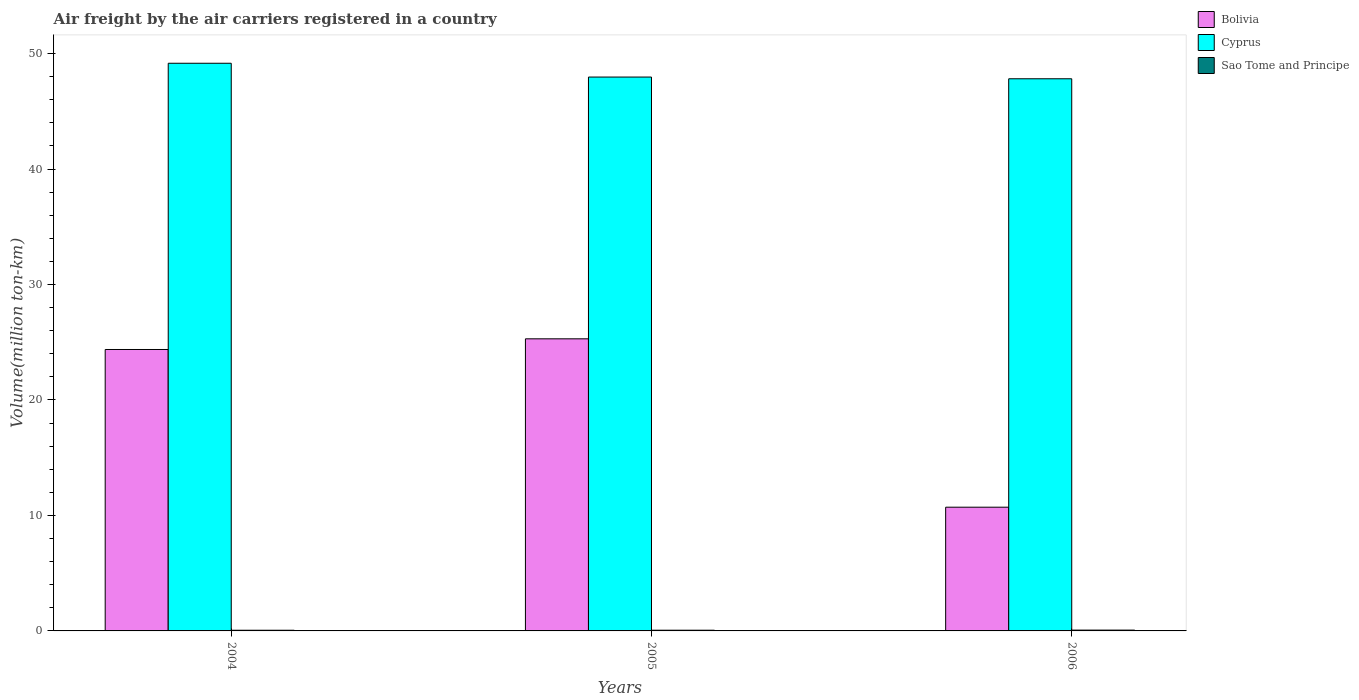Are the number of bars per tick equal to the number of legend labels?
Provide a short and direct response. Yes. Are the number of bars on each tick of the X-axis equal?
Make the answer very short. Yes. How many bars are there on the 1st tick from the right?
Offer a terse response. 3. In how many cases, is the number of bars for a given year not equal to the number of legend labels?
Ensure brevity in your answer.  0. What is the volume of the air carriers in Cyprus in 2006?
Provide a succinct answer. 47.81. Across all years, what is the maximum volume of the air carriers in Sao Tome and Principe?
Provide a succinct answer. 0.07. Across all years, what is the minimum volume of the air carriers in Cyprus?
Ensure brevity in your answer.  47.81. In which year was the volume of the air carriers in Bolivia minimum?
Give a very brief answer. 2006. What is the total volume of the air carriers in Sao Tome and Principe in the graph?
Offer a terse response. 0.19. What is the difference between the volume of the air carriers in Sao Tome and Principe in 2005 and that in 2006?
Your answer should be very brief. -0.01. What is the difference between the volume of the air carriers in Bolivia in 2005 and the volume of the air carriers in Sao Tome and Principe in 2006?
Your answer should be compact. 25.22. What is the average volume of the air carriers in Sao Tome and Principe per year?
Provide a short and direct response. 0.06. In the year 2004, what is the difference between the volume of the air carriers in Cyprus and volume of the air carriers in Sao Tome and Principe?
Your answer should be very brief. 49.1. In how many years, is the volume of the air carriers in Cyprus greater than 4 million ton-km?
Offer a terse response. 3. What is the ratio of the volume of the air carriers in Cyprus in 2004 to that in 2006?
Your response must be concise. 1.03. Is the volume of the air carriers in Sao Tome and Principe in 2004 less than that in 2006?
Provide a succinct answer. Yes. Is the difference between the volume of the air carriers in Cyprus in 2005 and 2006 greater than the difference between the volume of the air carriers in Sao Tome and Principe in 2005 and 2006?
Make the answer very short. Yes. What is the difference between the highest and the second highest volume of the air carriers in Cyprus?
Offer a very short reply. 1.2. What is the difference between the highest and the lowest volume of the air carriers in Cyprus?
Give a very brief answer. 1.34. In how many years, is the volume of the air carriers in Cyprus greater than the average volume of the air carriers in Cyprus taken over all years?
Ensure brevity in your answer.  1. What does the 3rd bar from the left in 2005 represents?
Give a very brief answer. Sao Tome and Principe. What does the 2nd bar from the right in 2006 represents?
Your answer should be very brief. Cyprus. How many years are there in the graph?
Offer a terse response. 3. What is the difference between two consecutive major ticks on the Y-axis?
Make the answer very short. 10. Does the graph contain any zero values?
Provide a short and direct response. No. Where does the legend appear in the graph?
Offer a terse response. Top right. How are the legend labels stacked?
Your answer should be very brief. Vertical. What is the title of the graph?
Your answer should be very brief. Air freight by the air carriers registered in a country. What is the label or title of the X-axis?
Provide a short and direct response. Years. What is the label or title of the Y-axis?
Provide a succinct answer. Volume(million ton-km). What is the Volume(million ton-km) of Bolivia in 2004?
Make the answer very short. 24.37. What is the Volume(million ton-km) in Cyprus in 2004?
Offer a terse response. 49.16. What is the Volume(million ton-km) in Sao Tome and Principe in 2004?
Ensure brevity in your answer.  0.06. What is the Volume(million ton-km) of Bolivia in 2005?
Offer a terse response. 25.3. What is the Volume(million ton-km) in Cyprus in 2005?
Ensure brevity in your answer.  47.96. What is the Volume(million ton-km) of Sao Tome and Principe in 2005?
Your answer should be very brief. 0.06. What is the Volume(million ton-km) of Bolivia in 2006?
Make the answer very short. 10.71. What is the Volume(million ton-km) of Cyprus in 2006?
Provide a short and direct response. 47.81. What is the Volume(million ton-km) in Sao Tome and Principe in 2006?
Your answer should be very brief. 0.07. Across all years, what is the maximum Volume(million ton-km) of Bolivia?
Provide a succinct answer. 25.3. Across all years, what is the maximum Volume(million ton-km) of Cyprus?
Your response must be concise. 49.16. Across all years, what is the maximum Volume(million ton-km) in Sao Tome and Principe?
Offer a terse response. 0.07. Across all years, what is the minimum Volume(million ton-km) of Bolivia?
Your answer should be compact. 10.71. Across all years, what is the minimum Volume(million ton-km) in Cyprus?
Offer a very short reply. 47.81. Across all years, what is the minimum Volume(million ton-km) in Sao Tome and Principe?
Make the answer very short. 0.06. What is the total Volume(million ton-km) of Bolivia in the graph?
Provide a succinct answer. 60.38. What is the total Volume(million ton-km) of Cyprus in the graph?
Make the answer very short. 144.94. What is the total Volume(million ton-km) of Sao Tome and Principe in the graph?
Offer a very short reply. 0.19. What is the difference between the Volume(million ton-km) in Bolivia in 2004 and that in 2005?
Provide a succinct answer. -0.92. What is the difference between the Volume(million ton-km) in Cyprus in 2004 and that in 2005?
Your answer should be very brief. 1.2. What is the difference between the Volume(million ton-km) in Sao Tome and Principe in 2004 and that in 2005?
Provide a succinct answer. -0. What is the difference between the Volume(million ton-km) in Bolivia in 2004 and that in 2006?
Provide a succinct answer. 13.66. What is the difference between the Volume(million ton-km) in Cyprus in 2004 and that in 2006?
Make the answer very short. 1.34. What is the difference between the Volume(million ton-km) of Sao Tome and Principe in 2004 and that in 2006?
Provide a short and direct response. -0.01. What is the difference between the Volume(million ton-km) in Bolivia in 2005 and that in 2006?
Make the answer very short. 14.58. What is the difference between the Volume(million ton-km) in Cyprus in 2005 and that in 2006?
Ensure brevity in your answer.  0.15. What is the difference between the Volume(million ton-km) of Sao Tome and Principe in 2005 and that in 2006?
Give a very brief answer. -0.01. What is the difference between the Volume(million ton-km) in Bolivia in 2004 and the Volume(million ton-km) in Cyprus in 2005?
Ensure brevity in your answer.  -23.59. What is the difference between the Volume(million ton-km) in Bolivia in 2004 and the Volume(million ton-km) in Sao Tome and Principe in 2005?
Keep it short and to the point. 24.31. What is the difference between the Volume(million ton-km) of Cyprus in 2004 and the Volume(million ton-km) of Sao Tome and Principe in 2005?
Your answer should be compact. 49.1. What is the difference between the Volume(million ton-km) of Bolivia in 2004 and the Volume(million ton-km) of Cyprus in 2006?
Your answer should be compact. -23.44. What is the difference between the Volume(million ton-km) in Bolivia in 2004 and the Volume(million ton-km) in Sao Tome and Principe in 2006?
Make the answer very short. 24.3. What is the difference between the Volume(million ton-km) in Cyprus in 2004 and the Volume(million ton-km) in Sao Tome and Principe in 2006?
Offer a terse response. 49.09. What is the difference between the Volume(million ton-km) in Bolivia in 2005 and the Volume(million ton-km) in Cyprus in 2006?
Make the answer very short. -22.52. What is the difference between the Volume(million ton-km) in Bolivia in 2005 and the Volume(million ton-km) in Sao Tome and Principe in 2006?
Offer a very short reply. 25.22. What is the difference between the Volume(million ton-km) of Cyprus in 2005 and the Volume(million ton-km) of Sao Tome and Principe in 2006?
Make the answer very short. 47.89. What is the average Volume(million ton-km) in Bolivia per year?
Keep it short and to the point. 20.13. What is the average Volume(million ton-km) in Cyprus per year?
Offer a very short reply. 48.31. What is the average Volume(million ton-km) in Sao Tome and Principe per year?
Give a very brief answer. 0.06. In the year 2004, what is the difference between the Volume(million ton-km) in Bolivia and Volume(million ton-km) in Cyprus?
Your answer should be very brief. -24.79. In the year 2004, what is the difference between the Volume(million ton-km) in Bolivia and Volume(million ton-km) in Sao Tome and Principe?
Ensure brevity in your answer.  24.31. In the year 2004, what is the difference between the Volume(million ton-km) of Cyprus and Volume(million ton-km) of Sao Tome and Principe?
Keep it short and to the point. 49.1. In the year 2005, what is the difference between the Volume(million ton-km) of Bolivia and Volume(million ton-km) of Cyprus?
Offer a terse response. -22.67. In the year 2005, what is the difference between the Volume(million ton-km) of Bolivia and Volume(million ton-km) of Sao Tome and Principe?
Provide a succinct answer. 25.23. In the year 2005, what is the difference between the Volume(million ton-km) in Cyprus and Volume(million ton-km) in Sao Tome and Principe?
Your response must be concise. 47.9. In the year 2006, what is the difference between the Volume(million ton-km) in Bolivia and Volume(million ton-km) in Cyprus?
Keep it short and to the point. -37.1. In the year 2006, what is the difference between the Volume(million ton-km) of Bolivia and Volume(million ton-km) of Sao Tome and Principe?
Your answer should be very brief. 10.64. In the year 2006, what is the difference between the Volume(million ton-km) of Cyprus and Volume(million ton-km) of Sao Tome and Principe?
Offer a very short reply. 47.74. What is the ratio of the Volume(million ton-km) in Bolivia in 2004 to that in 2005?
Give a very brief answer. 0.96. What is the ratio of the Volume(million ton-km) in Cyprus in 2004 to that in 2005?
Ensure brevity in your answer.  1.02. What is the ratio of the Volume(million ton-km) of Sao Tome and Principe in 2004 to that in 2005?
Offer a terse response. 0.95. What is the ratio of the Volume(million ton-km) of Bolivia in 2004 to that in 2006?
Give a very brief answer. 2.27. What is the ratio of the Volume(million ton-km) of Cyprus in 2004 to that in 2006?
Your response must be concise. 1.03. What is the ratio of the Volume(million ton-km) in Sao Tome and Principe in 2004 to that in 2006?
Make the answer very short. 0.83. What is the ratio of the Volume(million ton-km) in Bolivia in 2005 to that in 2006?
Give a very brief answer. 2.36. What is the ratio of the Volume(million ton-km) of Cyprus in 2005 to that in 2006?
Keep it short and to the point. 1. What is the ratio of the Volume(million ton-km) of Sao Tome and Principe in 2005 to that in 2006?
Your answer should be very brief. 0.87. What is the difference between the highest and the second highest Volume(million ton-km) in Bolivia?
Your answer should be very brief. 0.92. What is the difference between the highest and the second highest Volume(million ton-km) of Cyprus?
Keep it short and to the point. 1.2. What is the difference between the highest and the second highest Volume(million ton-km) of Sao Tome and Principe?
Your answer should be very brief. 0.01. What is the difference between the highest and the lowest Volume(million ton-km) of Bolivia?
Your answer should be compact. 14.58. What is the difference between the highest and the lowest Volume(million ton-km) of Cyprus?
Keep it short and to the point. 1.34. What is the difference between the highest and the lowest Volume(million ton-km) in Sao Tome and Principe?
Your response must be concise. 0.01. 